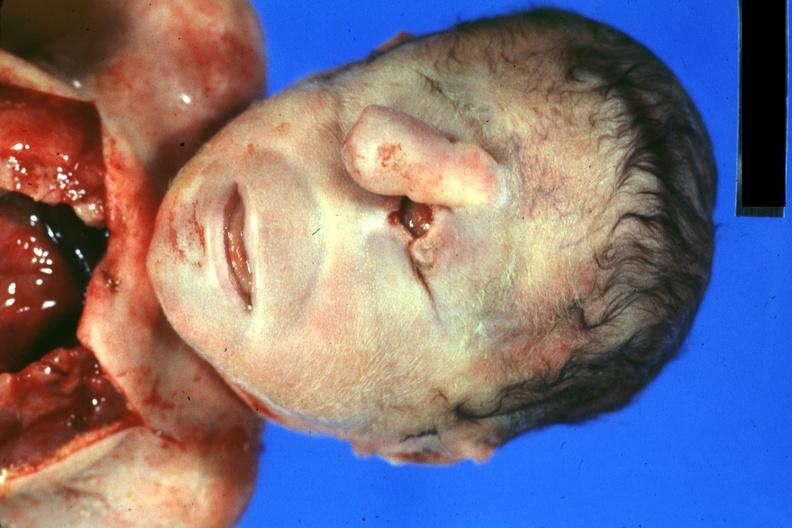s face present?
Answer the question using a single word or phrase. Yes 